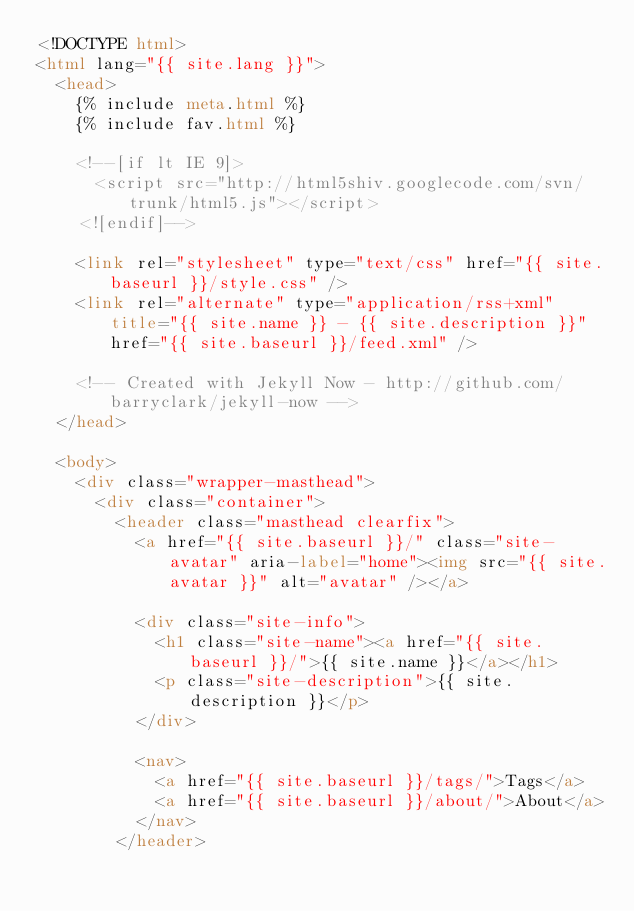<code> <loc_0><loc_0><loc_500><loc_500><_HTML_><!DOCTYPE html>
<html lang="{{ site.lang }}">
  <head>
    {% include meta.html %}
    {% include fav.html %}

    <!--[if lt IE 9]>
      <script src="http://html5shiv.googlecode.com/svn/trunk/html5.js"></script>
    <![endif]-->

    <link rel="stylesheet" type="text/css" href="{{ site.baseurl }}/style.css" />
    <link rel="alternate" type="application/rss+xml" title="{{ site.name }} - {{ site.description }}" href="{{ site.baseurl }}/feed.xml" />

    <!-- Created with Jekyll Now - http://github.com/barryclark/jekyll-now -->
  </head>

  <body>
    <div class="wrapper-masthead">
      <div class="container">
        <header class="masthead clearfix">
          <a href="{{ site.baseurl }}/" class="site-avatar" aria-label="home"><img src="{{ site.avatar }}" alt="avatar" /></a>

          <div class="site-info">
            <h1 class="site-name"><a href="{{ site.baseurl }}/">{{ site.name }}</a></h1>
            <p class="site-description">{{ site.description }}</p>
          </div>

          <nav>
            <a href="{{ site.baseurl }}/tags/">Tags</a>
            <a href="{{ site.baseurl }}/about/">About</a>
          </nav>
        </header></code> 